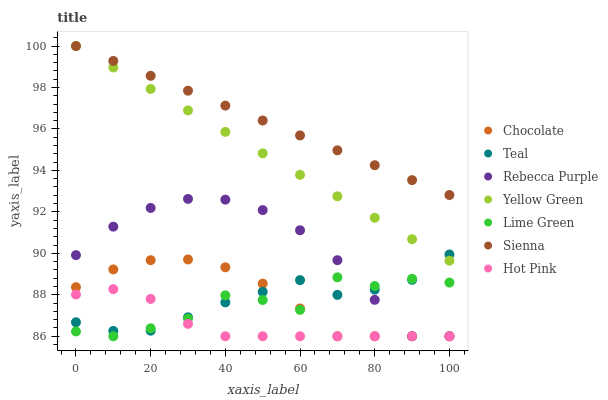Does Hot Pink have the minimum area under the curve?
Answer yes or no. Yes. Does Sienna have the maximum area under the curve?
Answer yes or no. Yes. Does Chocolate have the minimum area under the curve?
Answer yes or no. No. Does Chocolate have the maximum area under the curve?
Answer yes or no. No. Is Sienna the smoothest?
Answer yes or no. Yes. Is Lime Green the roughest?
Answer yes or no. Yes. Is Hot Pink the smoothest?
Answer yes or no. No. Is Hot Pink the roughest?
Answer yes or no. No. Does Hot Pink have the lowest value?
Answer yes or no. Yes. Does Sienna have the lowest value?
Answer yes or no. No. Does Sienna have the highest value?
Answer yes or no. Yes. Does Chocolate have the highest value?
Answer yes or no. No. Is Chocolate less than Sienna?
Answer yes or no. Yes. Is Sienna greater than Rebecca Purple?
Answer yes or no. Yes. Does Lime Green intersect Hot Pink?
Answer yes or no. Yes. Is Lime Green less than Hot Pink?
Answer yes or no. No. Is Lime Green greater than Hot Pink?
Answer yes or no. No. Does Chocolate intersect Sienna?
Answer yes or no. No. 